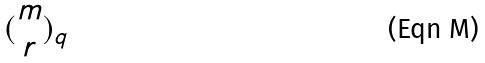<formula> <loc_0><loc_0><loc_500><loc_500>( \begin{matrix} m \\ r \end{matrix} ) _ { q }</formula> 